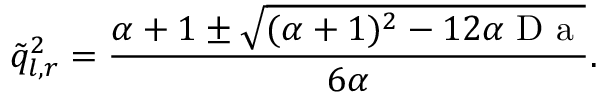<formula> <loc_0><loc_0><loc_500><loc_500>\tilde { q } _ { l , r } ^ { 2 } = \frac { \alpha + 1 \pm \sqrt { ( \alpha + 1 ) ^ { 2 } - 1 2 \alpha D a } } { 6 \alpha } .</formula> 